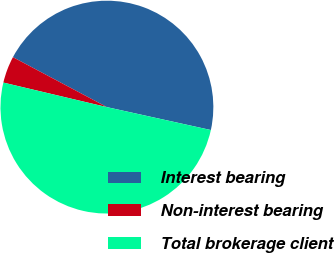<chart> <loc_0><loc_0><loc_500><loc_500><pie_chart><fcel>Interest bearing<fcel>Non-interest bearing<fcel>Total brokerage client<nl><fcel>45.68%<fcel>4.07%<fcel>50.25%<nl></chart> 